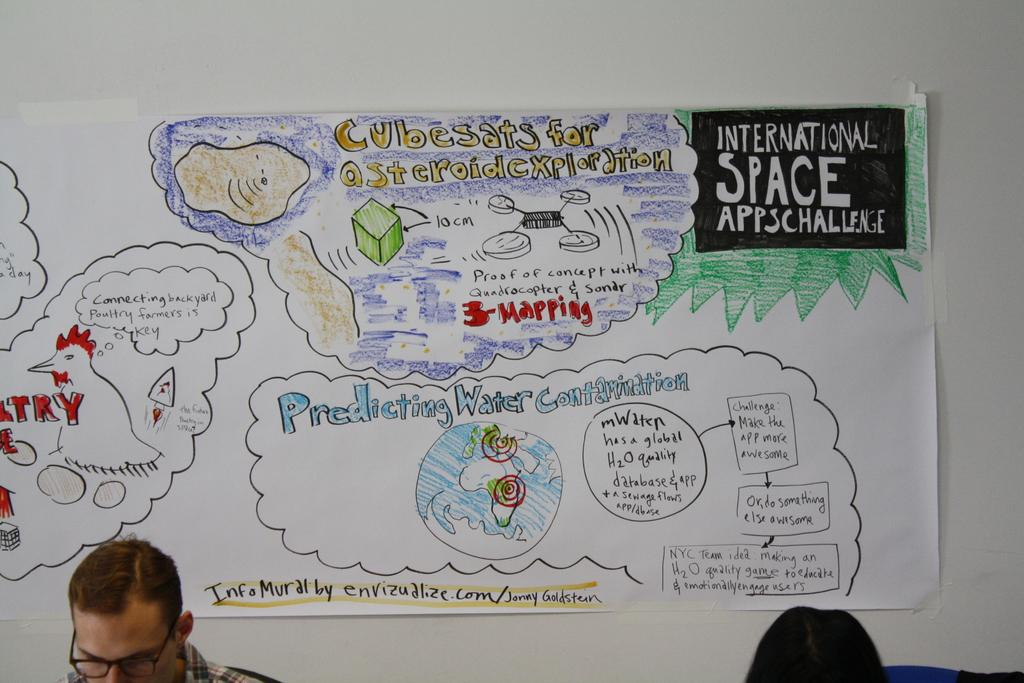What is on the paper that is visible in the image? There is writing and a drawing on the paper in the image. What else can be seen in the image besides the paper? There is a man standing in the image. How many bears are rolling around on the paper in the image? There are no bears present in the image, and they are not rolling around on the paper. 